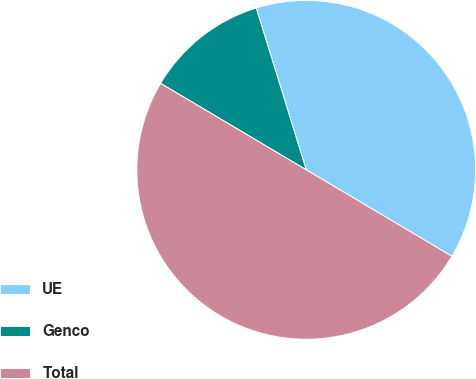Convert chart. <chart><loc_0><loc_0><loc_500><loc_500><pie_chart><fcel>UE<fcel>Genco<fcel>Total<nl><fcel>38.3%<fcel>11.7%<fcel>50.0%<nl></chart> 